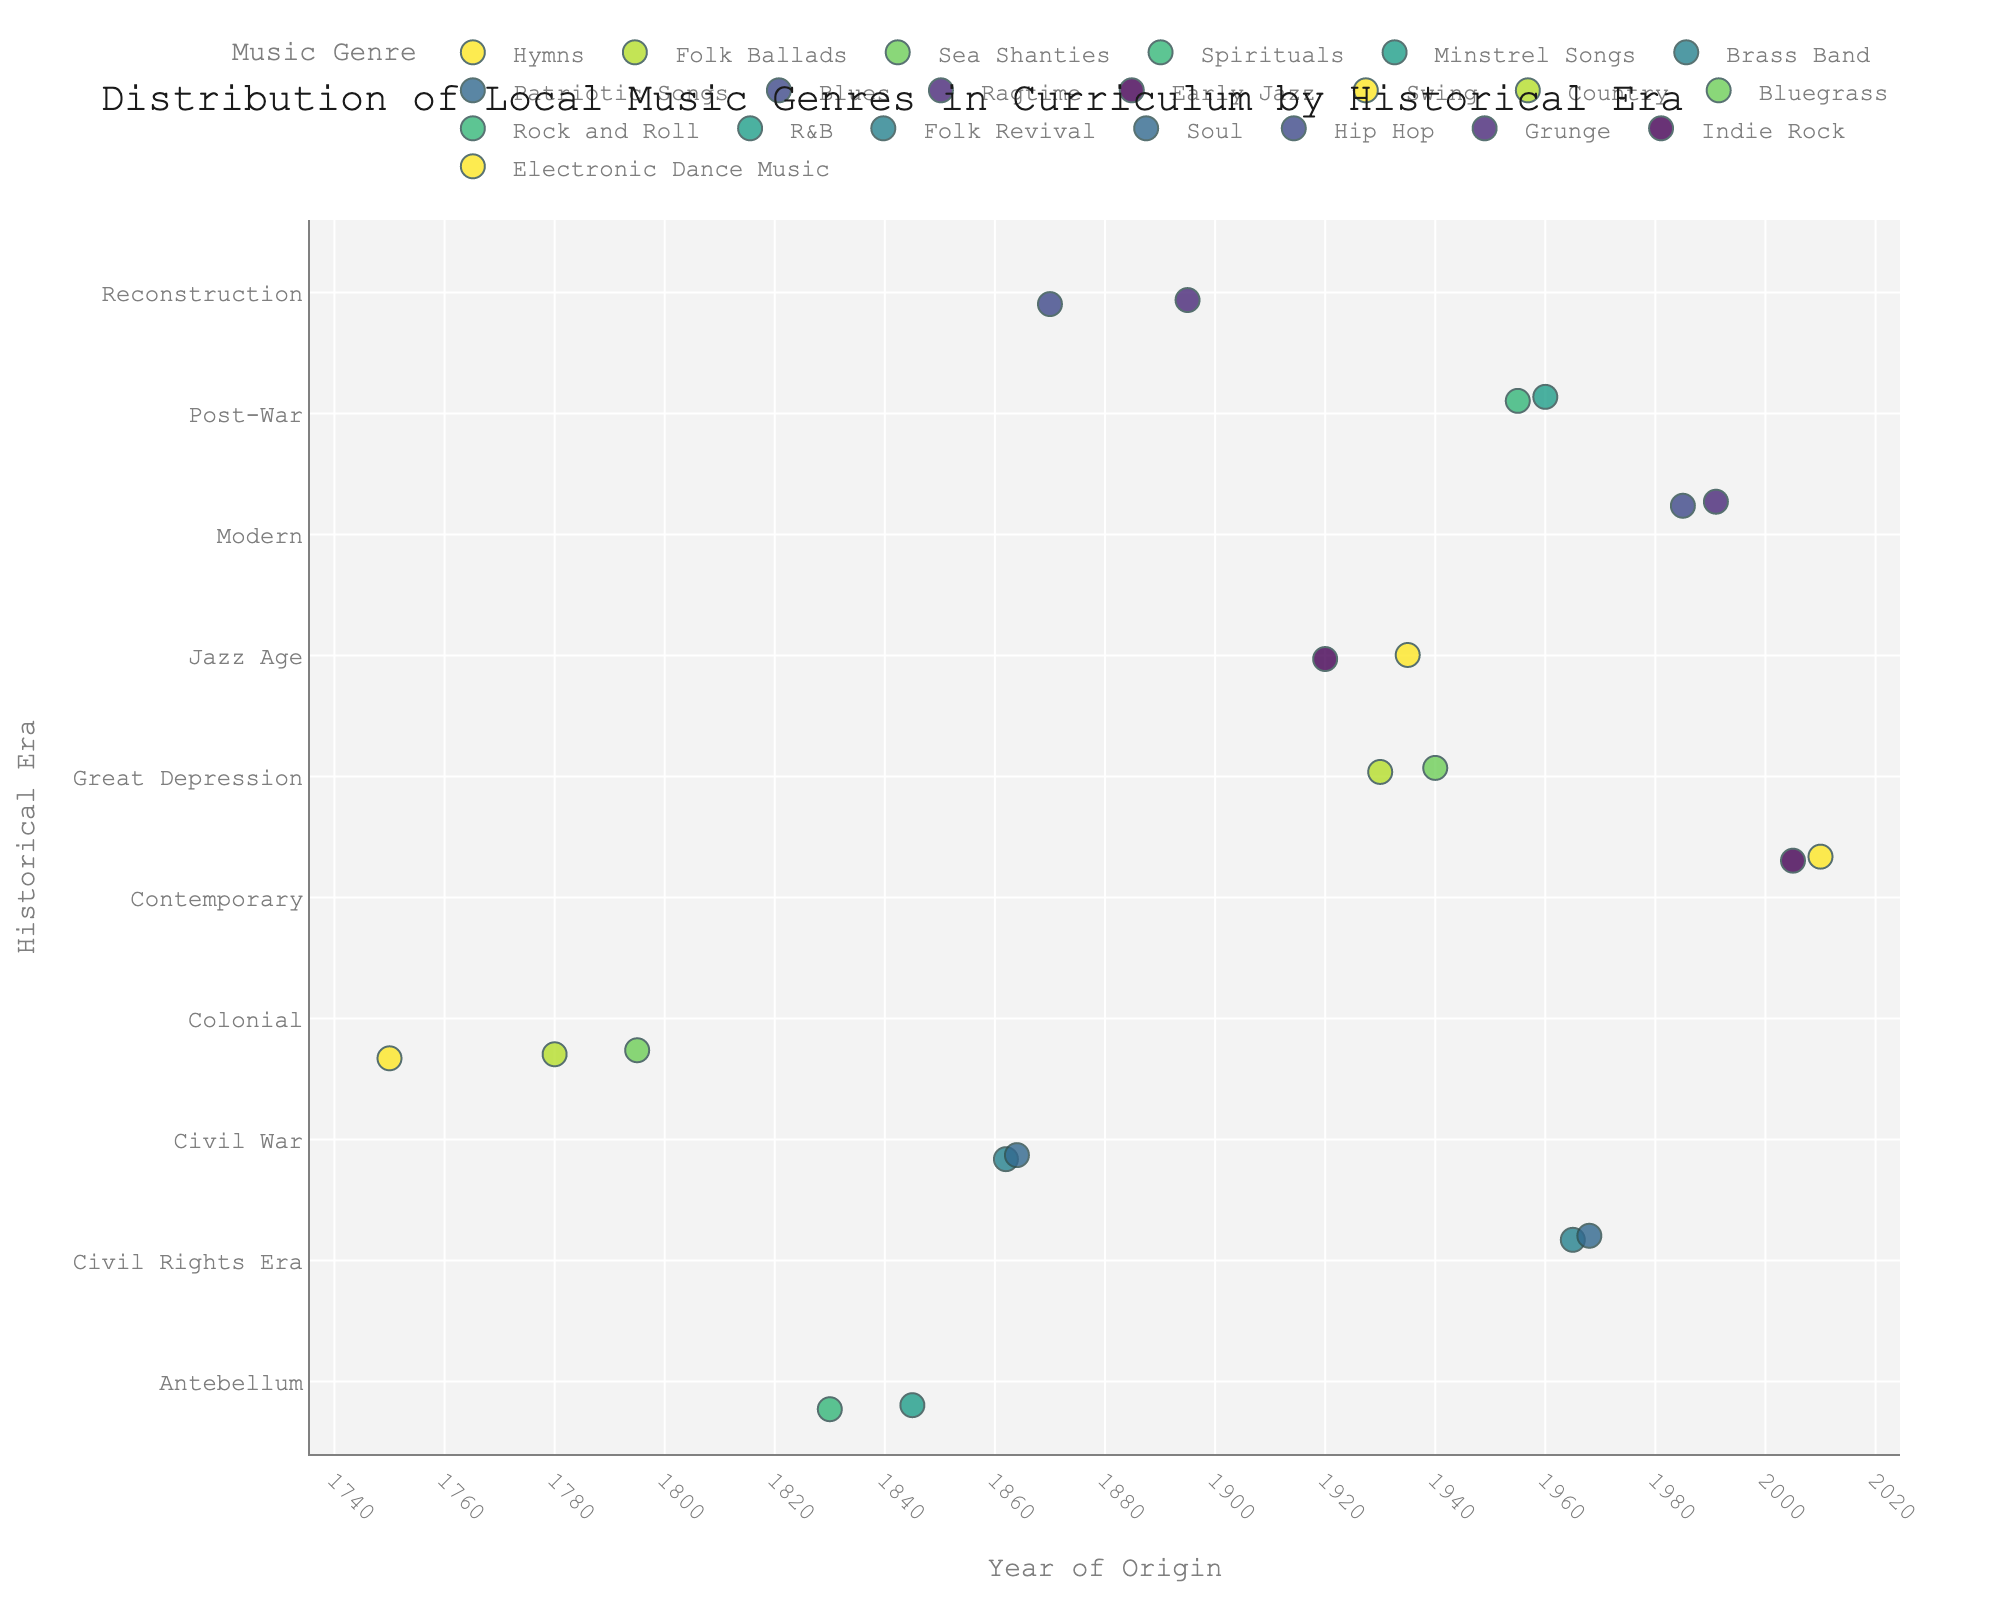what is the title of the plot? The title of the plot is usually located at the top of the figure and provides a summary of what the plot is about.
Answer: Distribution of Local Music Genres in Curriculum by Historical Era how many data points represent the Colonial era? To find out how many data points represent the Colonial era, look for markers or points aligned with the "Colonial" category on the y-axis. Count these points.
Answer: 3 which era has the latest year of origin for the represented music genres? Look for the point with the highest value on the x-axis and then check which era it corresponds to on the y-axis.
Answer: Contemporary which music genre originated in the year 1920? Locate the marker corresponding to the year 1920 on the x-axis and find the label of the point on the y-axis to identify the genre.
Answer: Early Jazz what is the range of years represented in the Civil Rights Era? Identify the markers for the Civil Rights Era on the y-axis and check their positions on the x-axis to find the earliest and latest years.
Answer: 1965 to 1968 which era has the most diversity in music genres based on the plot? Count the different genres represented by distinct points for each era on the y-axis. The era with the highest number of distinct genres has the most diversity.
Answer: Modern what is the average year of origin for music genres in the Great Depression era? Find the years corresponding to points in the Great Depression era and calculate their average. Sum the years and divide by the number of data points.
Answer: 1935 which era represents the transition from brass band music to blues? Look at the positions of brass band and blues genres on the plot and identify the eras they are associated with to find the transition point.
Answer: Civil War to Reconstruction how many total musical genres are represented across all eras? Count the total number of distinct genre labels shown in the legend or on the plot.
Answer: 20 compare the years of origin for Swing and Folk Revival. which one originated earlier? Locate the points for Swing and Folk Revival on the x-axis and compare their year values to see which one is earlier.
Answer: Swing 